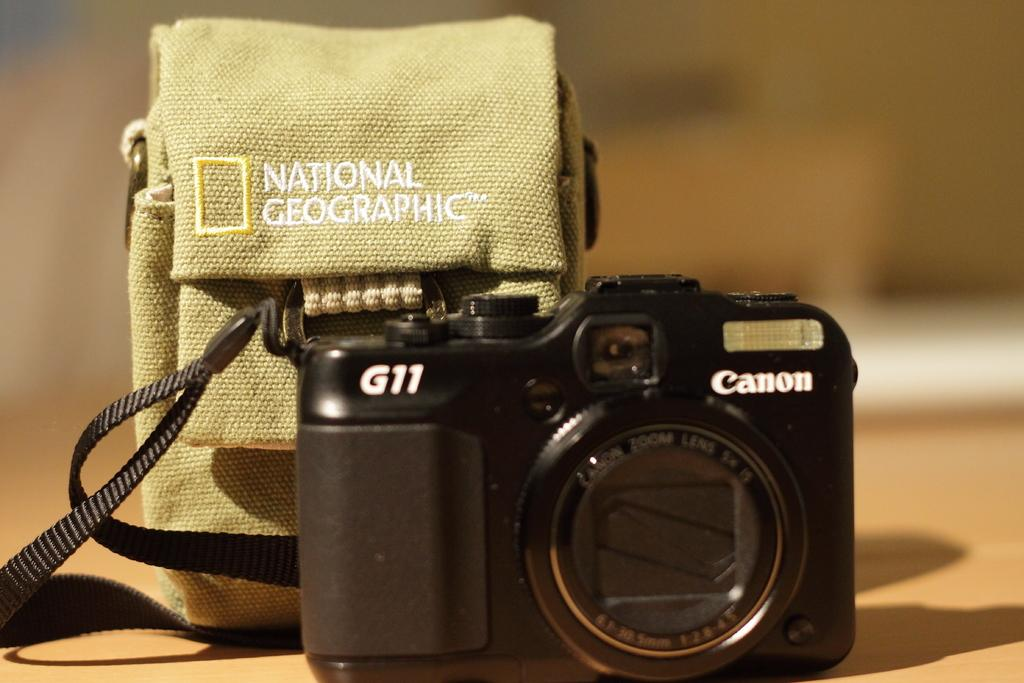What object can be seen in the image besides the camera? There is a bag in the image. Where are the bag and camera located in the image? Both the bag and the camera are placed on a surface. What is the condition of the background in the image? The background of the image is blurry. What type of oven can be seen in the background of the image? There is no oven present in the image; the background is blurry. Is there a branch visible in the image? There is no branch visible in the image. 